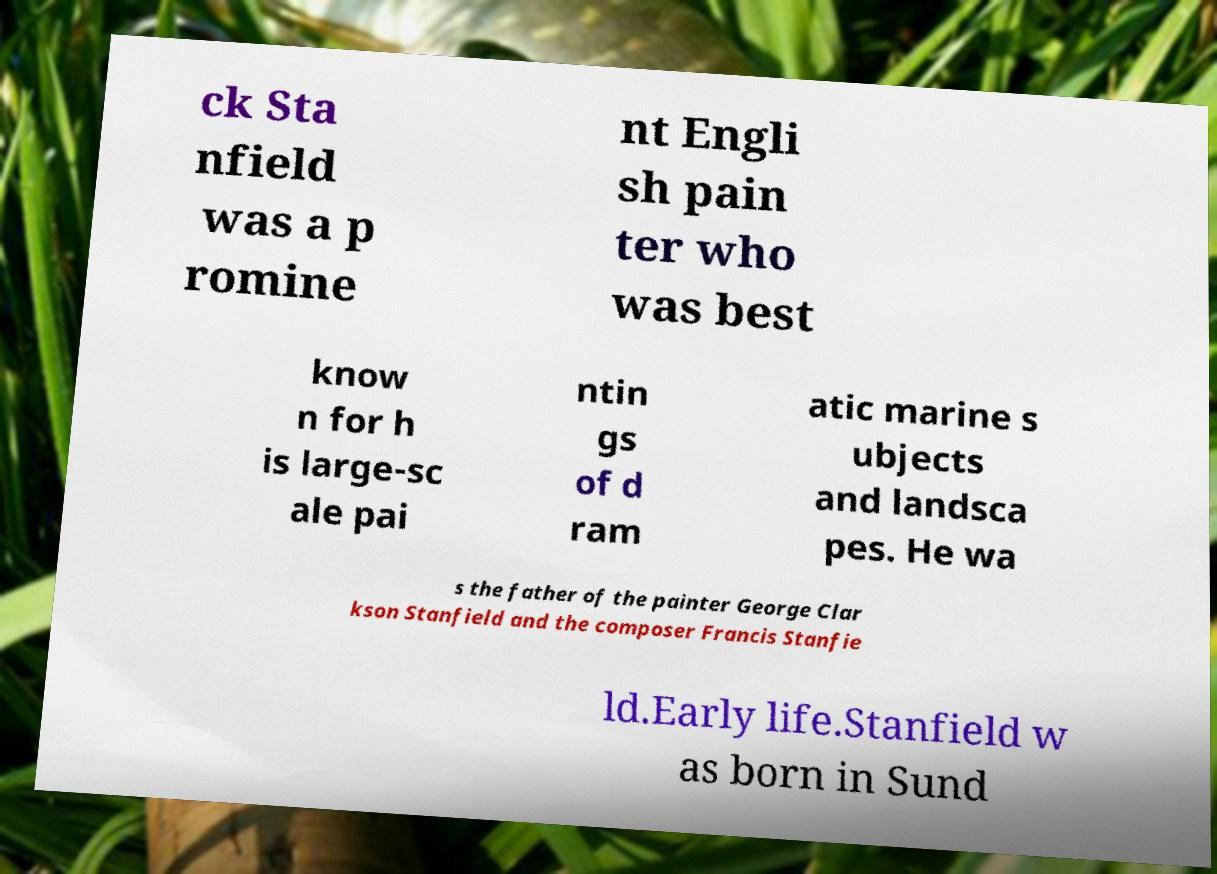I need the written content from this picture converted into text. Can you do that? ck Sta nfield was a p romine nt Engli sh pain ter who was best know n for h is large-sc ale pai ntin gs of d ram atic marine s ubjects and landsca pes. He wa s the father of the painter George Clar kson Stanfield and the composer Francis Stanfie ld.Early life.Stanfield w as born in Sund 